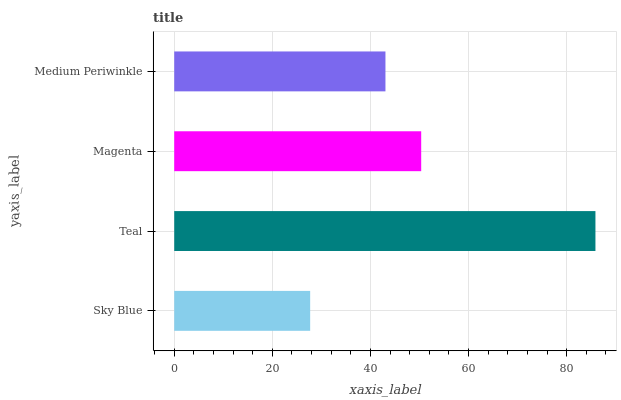Is Sky Blue the minimum?
Answer yes or no. Yes. Is Teal the maximum?
Answer yes or no. Yes. Is Magenta the minimum?
Answer yes or no. No. Is Magenta the maximum?
Answer yes or no. No. Is Teal greater than Magenta?
Answer yes or no. Yes. Is Magenta less than Teal?
Answer yes or no. Yes. Is Magenta greater than Teal?
Answer yes or no. No. Is Teal less than Magenta?
Answer yes or no. No. Is Magenta the high median?
Answer yes or no. Yes. Is Medium Periwinkle the low median?
Answer yes or no. Yes. Is Teal the high median?
Answer yes or no. No. Is Teal the low median?
Answer yes or no. No. 